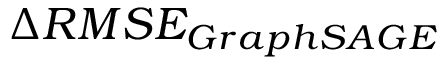Convert formula to latex. <formula><loc_0><loc_0><loc_500><loc_500>\Delta R M S E _ { G r a p h S A G E }</formula> 